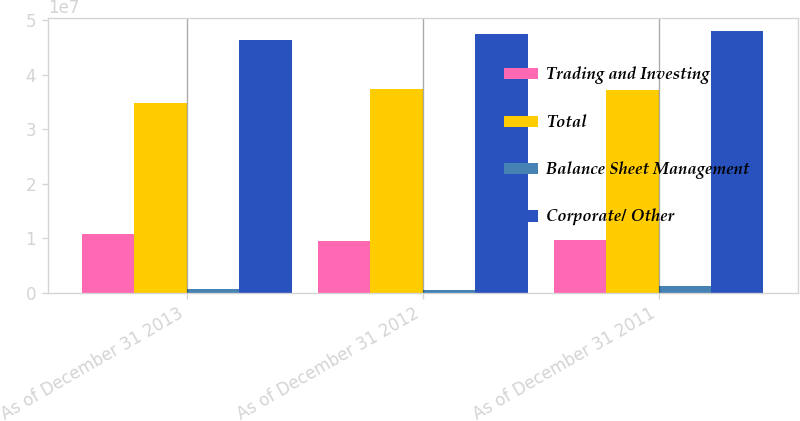<chart> <loc_0><loc_0><loc_500><loc_500><stacked_bar_chart><ecel><fcel>As of December 31 2013<fcel>As of December 31 2012<fcel>As of December 31 2011<nl><fcel>Trading and Investing<fcel>1.082e+07<fcel>9.50528e+06<fcel>9.60802e+06<nl><fcel>Total<fcel>3.47839e+07<fcel>3.73056e+07<fcel>3.71231e+07<nl><fcel>Balance Sheet Management<fcel>675966<fcel>575859<fcel>1.20931e+06<nl><fcel>Corporate/ Other<fcel>4.62799e+07<fcel>4.73867e+07<fcel>4.79405e+07<nl></chart> 